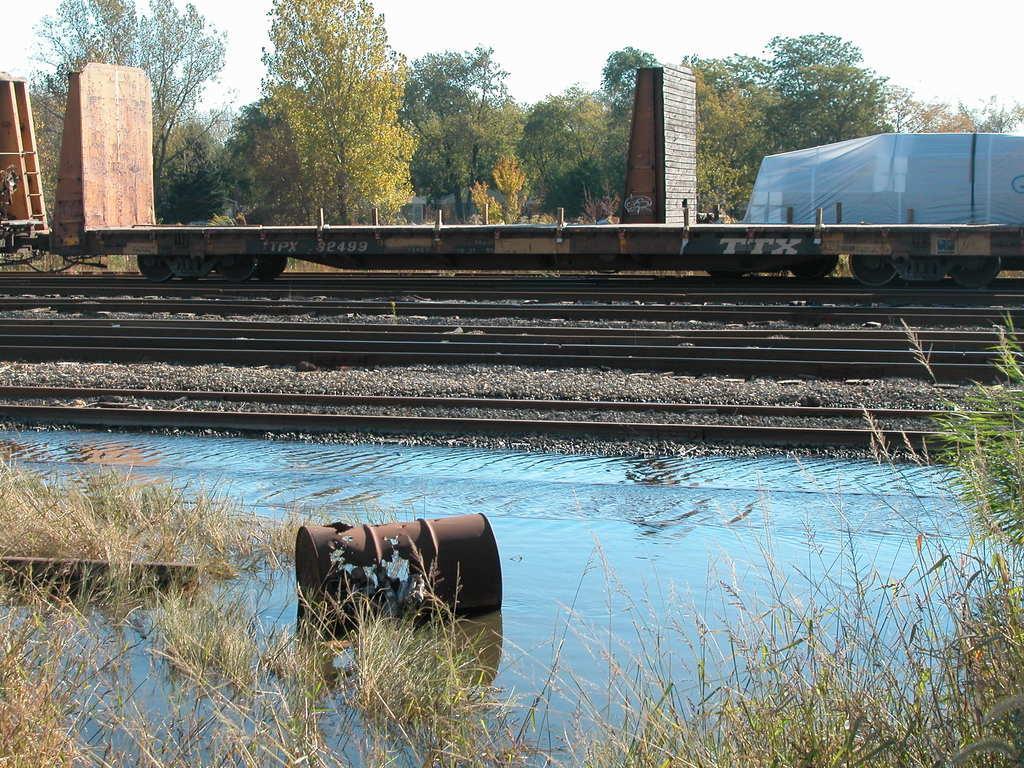Could you give a brief overview of what you see in this image? In the image we can see there are railway tracks and there is a train on the railway track. Behind there are trees. 